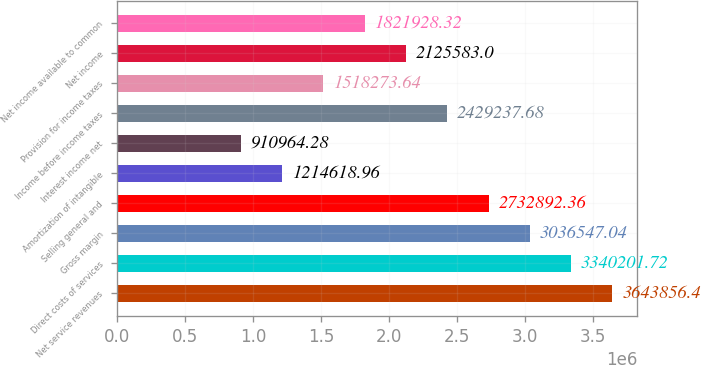Convert chart. <chart><loc_0><loc_0><loc_500><loc_500><bar_chart><fcel>Net service revenues<fcel>Direct costs of services<fcel>Gross margin<fcel>Selling general and<fcel>Amortization of intangible<fcel>Interest income net<fcel>Income before income taxes<fcel>Provision for income taxes<fcel>Net income<fcel>Net income available to common<nl><fcel>3.64386e+06<fcel>3.3402e+06<fcel>3.03655e+06<fcel>2.73289e+06<fcel>1.21462e+06<fcel>910964<fcel>2.42924e+06<fcel>1.51827e+06<fcel>2.12558e+06<fcel>1.82193e+06<nl></chart> 